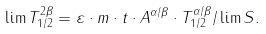Convert formula to latex. <formula><loc_0><loc_0><loc_500><loc_500>\lim T _ { 1 / 2 } ^ { 2 \beta } = \varepsilon \cdot m \cdot t \cdot A ^ { \alpha / \beta } \cdot T _ { 1 / 2 } ^ { \alpha / \beta } / \lim S .</formula> 